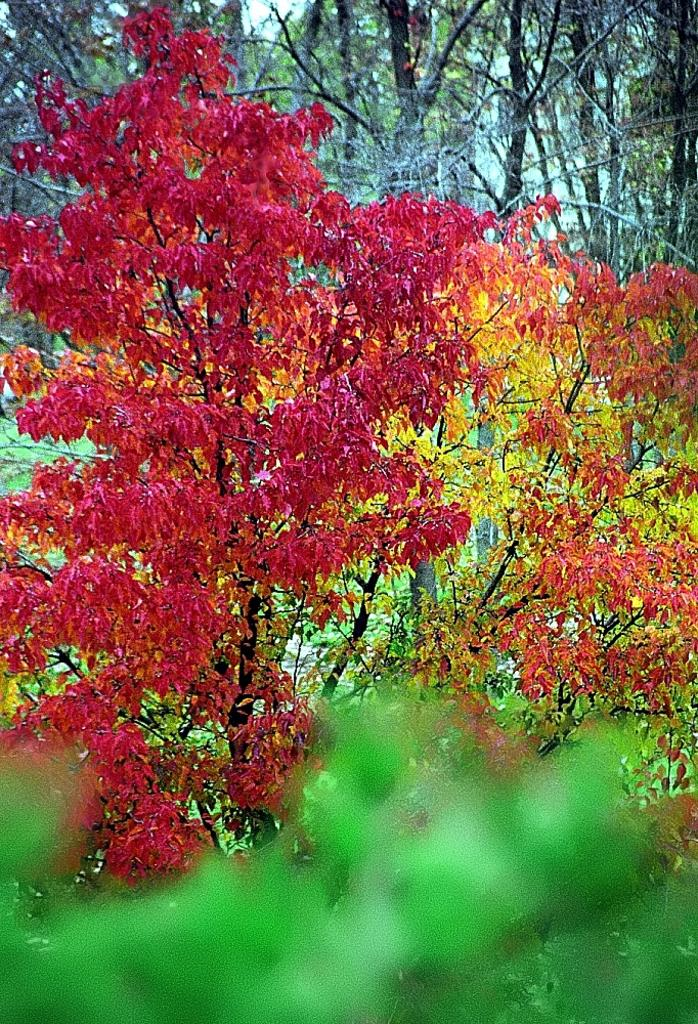What type of vegetation can be seen in the image? There are trees in the image. Can you describe the leaves on the trees in the image? There are different colors of leaves in the image. What type of joke does the dad tell in the image? There is no dad or joke present in the image; it only features trees with different colored leaves. 